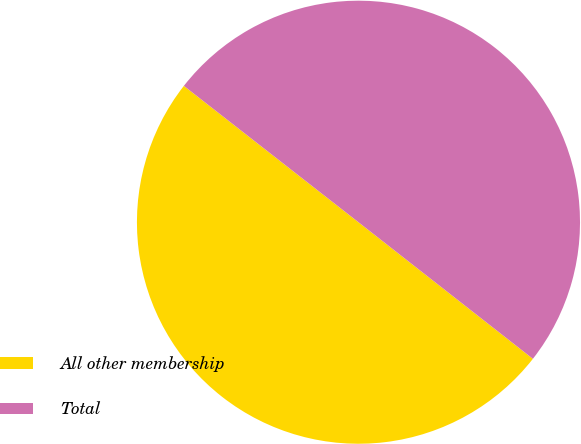<chart> <loc_0><loc_0><loc_500><loc_500><pie_chart><fcel>All other membership<fcel>Total<nl><fcel>49.98%<fcel>50.02%<nl></chart> 